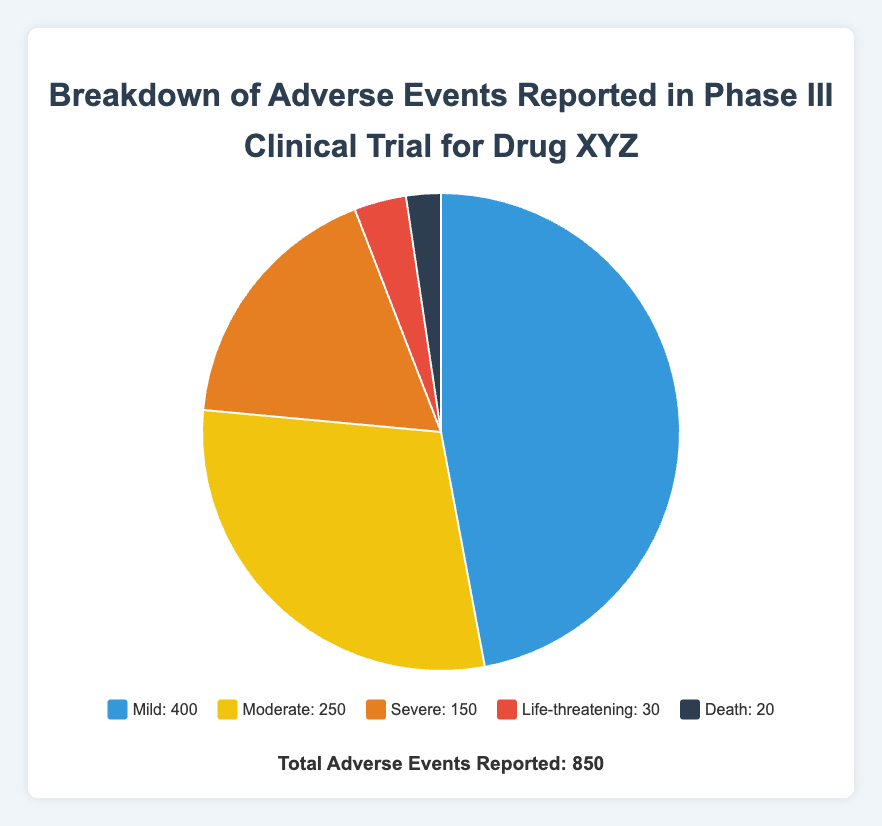What is the total number of "mild" adverse events reported? From the legend data, the number of "mild" adverse events reported is 400. By simply referring to the legend, you can see the number labeled next to "Mild."
Answer: 400 What percentage of total adverse events were classified as "moderate"? First, find the count of "moderate" adverse events, which is 250. Then, divide by the total number of adverse events (850) and multiply by 100 to get the percentage: (250/850) * 100 ≈ 29.4%.
Answer: 29.4% How many more "mild" adverse events were reported compared to "severe" adverse events? The count for "mild" adverse events is 400, and for "severe" it is 150. Subtract the count of "severe" from "mild": 400 - 150 = 250.
Answer: 250 What is the total number of adverse events reported that were classified as either "life-threatening" or "death"? Add the counts for "life-threatening" events (30) and "death" events (20): 30 + 20 = 50.
Answer: 50 Which category of adverse events had the least occurrences? From the legend, the "Death" category has the lowest count, which is 20.
Answer: Death What is the approximate ratio of "mild" to "moderate" adverse events? The count for "mild" events is 400 and for "moderate" is 250. The ratio is 400 to 250. Simplifying, the ratio is 400/250 = 8/5 = 1.6:1.
Answer: 1.6:1 Which categories together constitute more than 50% of the total adverse events reported? Calculate the percentages: "mild" (400/850 ≈ 47.1%), "moderate" (250/850 ≈ 29.4%), "severe" (150/850 ≈ 17.6%), "life-threatening" (30/850 ≈ 3.5%), and "death" (20/850 ≈ 2.3%). "Mild" alone is 47.1%, which isn't enough, but when combined with "moderate" (47.1% + 29.4% ≈ 76.5%), they together make over 50%.
Answer: Mild and Moderate What can be inferred about the severity distribution of adverse events from the colors of the pie chart? The colors indicate a gradient with "mild" adverse events in a lighter color transitioning to darker colors for more severe categories, suggesting that more severe events are fewer in number.
Answer: More severe events are fewer What is the difference between the total number of "mild" and "life-threatening" events? Subtract the "life-threatening" count (30) from the "mild" count (400): 400 - 30 = 370.
Answer: 370 Which section of the pie chart is the second largest in size? The largest section is for "mild" events (400). The next largest is "moderate" events with a count of 250.
Answer: Moderate 